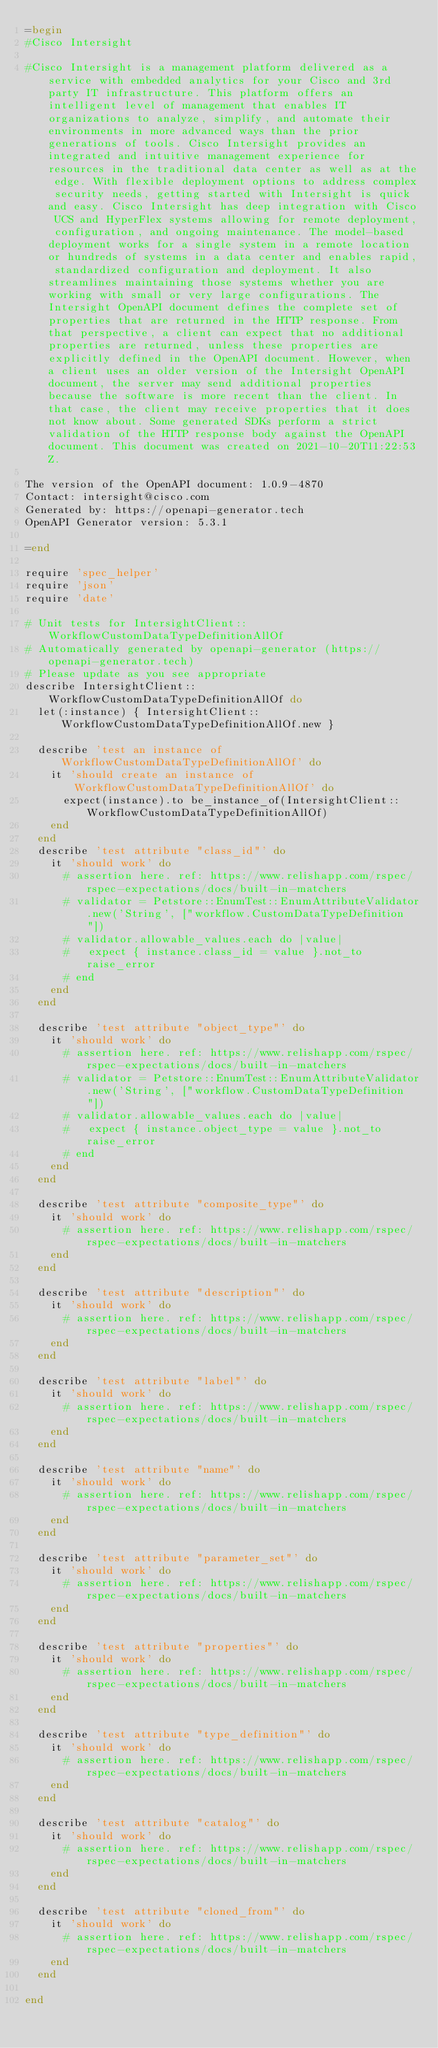<code> <loc_0><loc_0><loc_500><loc_500><_Ruby_>=begin
#Cisco Intersight

#Cisco Intersight is a management platform delivered as a service with embedded analytics for your Cisco and 3rd party IT infrastructure. This platform offers an intelligent level of management that enables IT organizations to analyze, simplify, and automate their environments in more advanced ways than the prior generations of tools. Cisco Intersight provides an integrated and intuitive management experience for resources in the traditional data center as well as at the edge. With flexible deployment options to address complex security needs, getting started with Intersight is quick and easy. Cisco Intersight has deep integration with Cisco UCS and HyperFlex systems allowing for remote deployment, configuration, and ongoing maintenance. The model-based deployment works for a single system in a remote location or hundreds of systems in a data center and enables rapid, standardized configuration and deployment. It also streamlines maintaining those systems whether you are working with small or very large configurations. The Intersight OpenAPI document defines the complete set of properties that are returned in the HTTP response. From that perspective, a client can expect that no additional properties are returned, unless these properties are explicitly defined in the OpenAPI document. However, when a client uses an older version of the Intersight OpenAPI document, the server may send additional properties because the software is more recent than the client. In that case, the client may receive properties that it does not know about. Some generated SDKs perform a strict validation of the HTTP response body against the OpenAPI document. This document was created on 2021-10-20T11:22:53Z.

The version of the OpenAPI document: 1.0.9-4870
Contact: intersight@cisco.com
Generated by: https://openapi-generator.tech
OpenAPI Generator version: 5.3.1

=end

require 'spec_helper'
require 'json'
require 'date'

# Unit tests for IntersightClient::WorkflowCustomDataTypeDefinitionAllOf
# Automatically generated by openapi-generator (https://openapi-generator.tech)
# Please update as you see appropriate
describe IntersightClient::WorkflowCustomDataTypeDefinitionAllOf do
  let(:instance) { IntersightClient::WorkflowCustomDataTypeDefinitionAllOf.new }

  describe 'test an instance of WorkflowCustomDataTypeDefinitionAllOf' do
    it 'should create an instance of WorkflowCustomDataTypeDefinitionAllOf' do
      expect(instance).to be_instance_of(IntersightClient::WorkflowCustomDataTypeDefinitionAllOf)
    end
  end
  describe 'test attribute "class_id"' do
    it 'should work' do
      # assertion here. ref: https://www.relishapp.com/rspec/rspec-expectations/docs/built-in-matchers
      # validator = Petstore::EnumTest::EnumAttributeValidator.new('String', ["workflow.CustomDataTypeDefinition"])
      # validator.allowable_values.each do |value|
      #   expect { instance.class_id = value }.not_to raise_error
      # end
    end
  end

  describe 'test attribute "object_type"' do
    it 'should work' do
      # assertion here. ref: https://www.relishapp.com/rspec/rspec-expectations/docs/built-in-matchers
      # validator = Petstore::EnumTest::EnumAttributeValidator.new('String', ["workflow.CustomDataTypeDefinition"])
      # validator.allowable_values.each do |value|
      #   expect { instance.object_type = value }.not_to raise_error
      # end
    end
  end

  describe 'test attribute "composite_type"' do
    it 'should work' do
      # assertion here. ref: https://www.relishapp.com/rspec/rspec-expectations/docs/built-in-matchers
    end
  end

  describe 'test attribute "description"' do
    it 'should work' do
      # assertion here. ref: https://www.relishapp.com/rspec/rspec-expectations/docs/built-in-matchers
    end
  end

  describe 'test attribute "label"' do
    it 'should work' do
      # assertion here. ref: https://www.relishapp.com/rspec/rspec-expectations/docs/built-in-matchers
    end
  end

  describe 'test attribute "name"' do
    it 'should work' do
      # assertion here. ref: https://www.relishapp.com/rspec/rspec-expectations/docs/built-in-matchers
    end
  end

  describe 'test attribute "parameter_set"' do
    it 'should work' do
      # assertion here. ref: https://www.relishapp.com/rspec/rspec-expectations/docs/built-in-matchers
    end
  end

  describe 'test attribute "properties"' do
    it 'should work' do
      # assertion here. ref: https://www.relishapp.com/rspec/rspec-expectations/docs/built-in-matchers
    end
  end

  describe 'test attribute "type_definition"' do
    it 'should work' do
      # assertion here. ref: https://www.relishapp.com/rspec/rspec-expectations/docs/built-in-matchers
    end
  end

  describe 'test attribute "catalog"' do
    it 'should work' do
      # assertion here. ref: https://www.relishapp.com/rspec/rspec-expectations/docs/built-in-matchers
    end
  end

  describe 'test attribute "cloned_from"' do
    it 'should work' do
      # assertion here. ref: https://www.relishapp.com/rspec/rspec-expectations/docs/built-in-matchers
    end
  end

end
</code> 